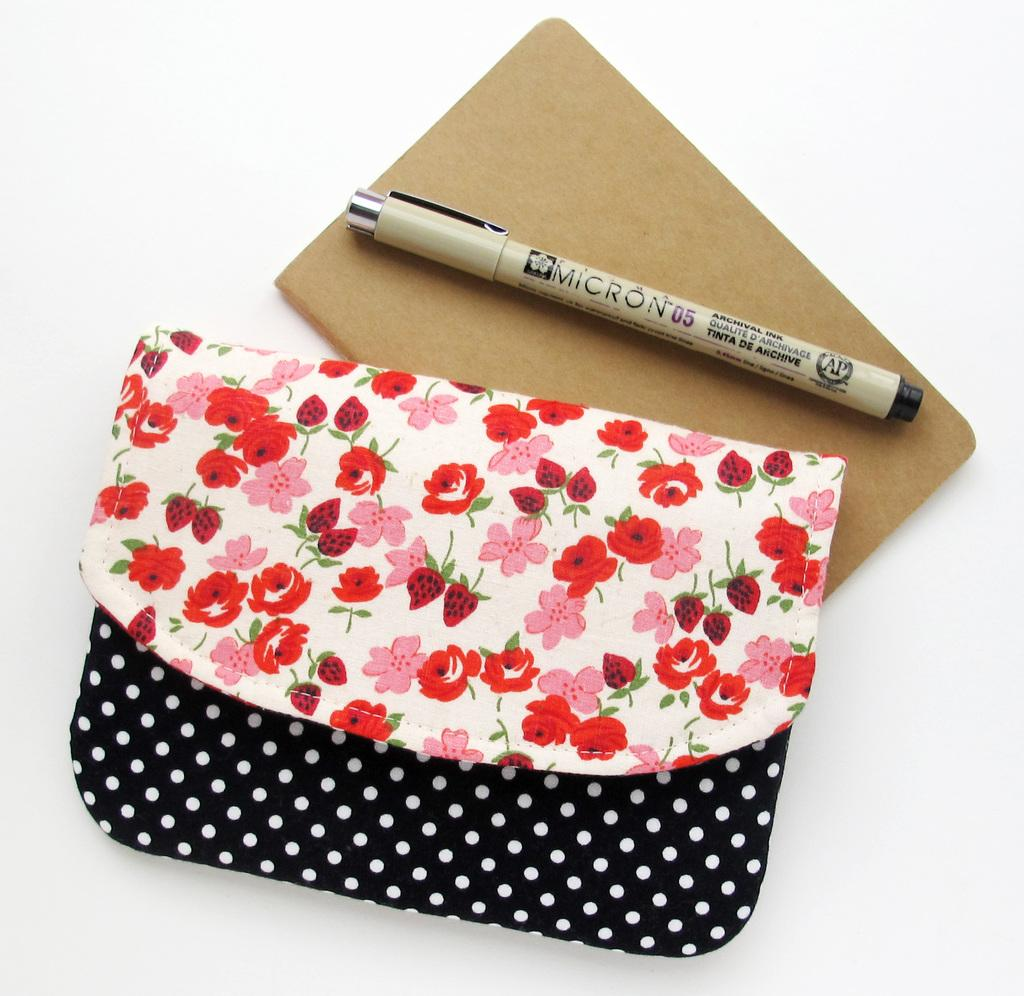What is located in the middle of the image? There is a purse and a book in the middle of the image. What is inside the book? There is a pen in the book. What color is the background of the image? The background of the image is white. What type of dress is being worn by the pen in the image? There is no dress present in the image, as the pen is an inanimate object and does not wear clothing. 